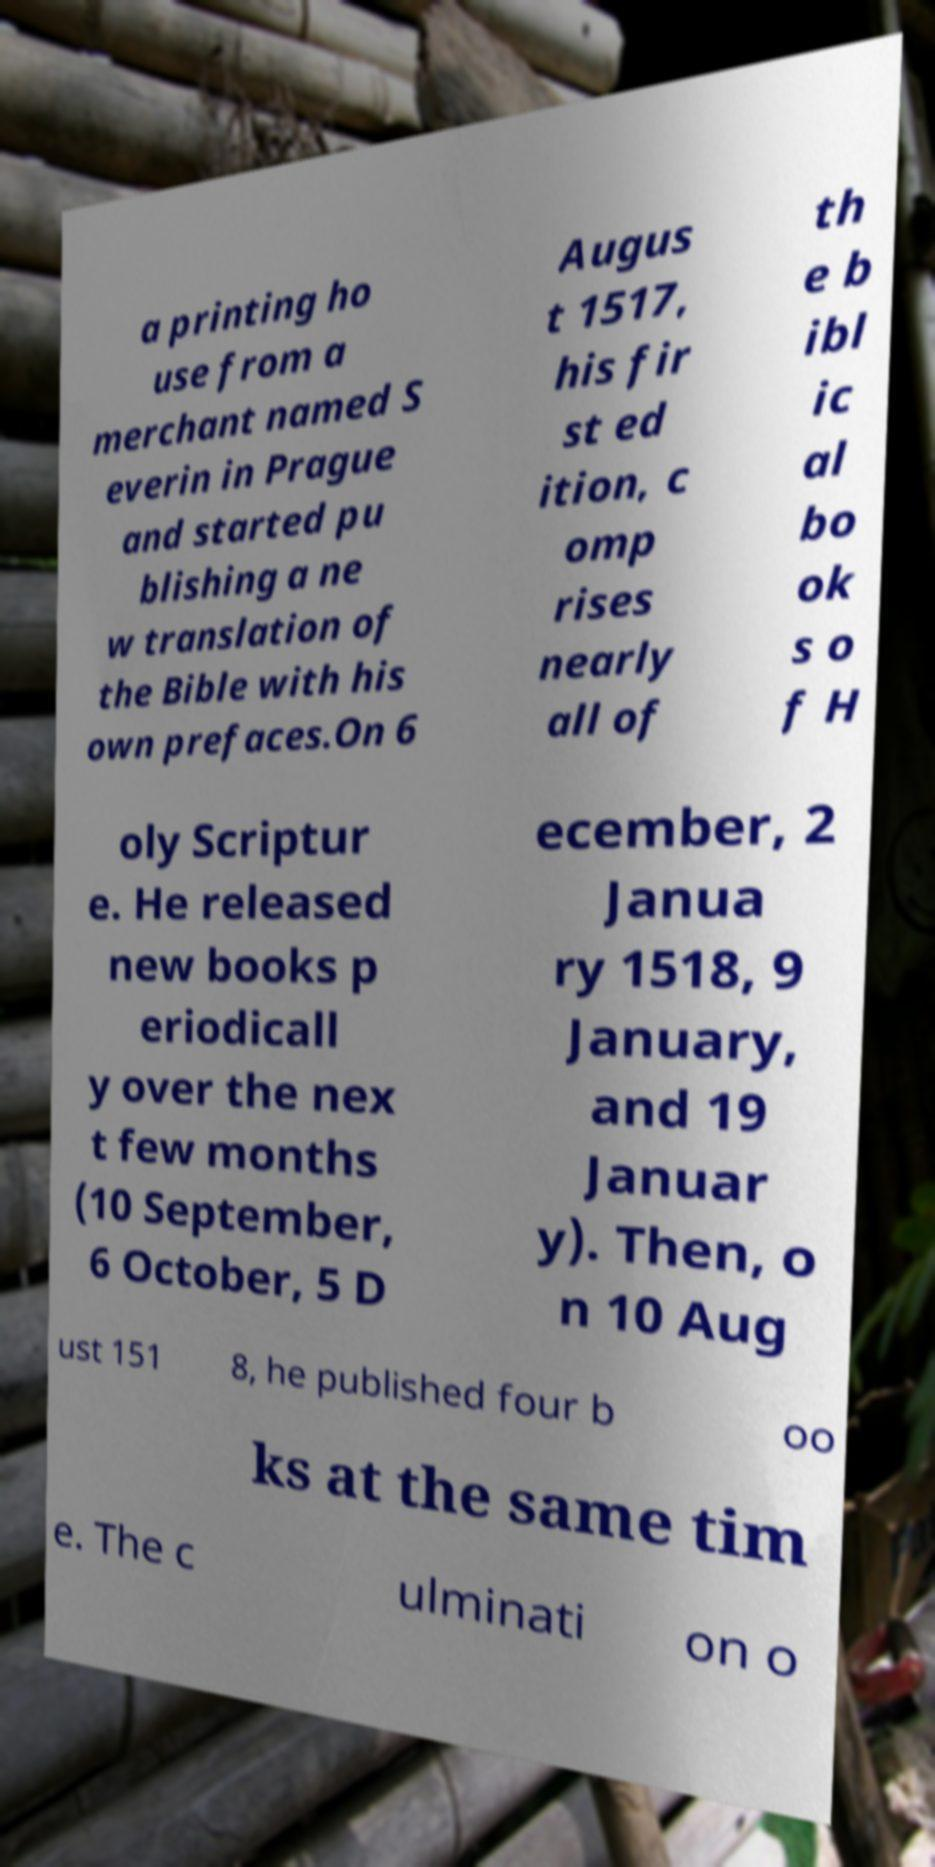Can you accurately transcribe the text from the provided image for me? a printing ho use from a merchant named S everin in Prague and started pu blishing a ne w translation of the Bible with his own prefaces.On 6 Augus t 1517, his fir st ed ition, c omp rises nearly all of th e b ibl ic al bo ok s o f H oly Scriptur e. He released new books p eriodicall y over the nex t few months (10 September, 6 October, 5 D ecember, 2 Janua ry 1518, 9 January, and 19 Januar y). Then, o n 10 Aug ust 151 8, he published four b oo ks at the same tim e. The c ulminati on o 